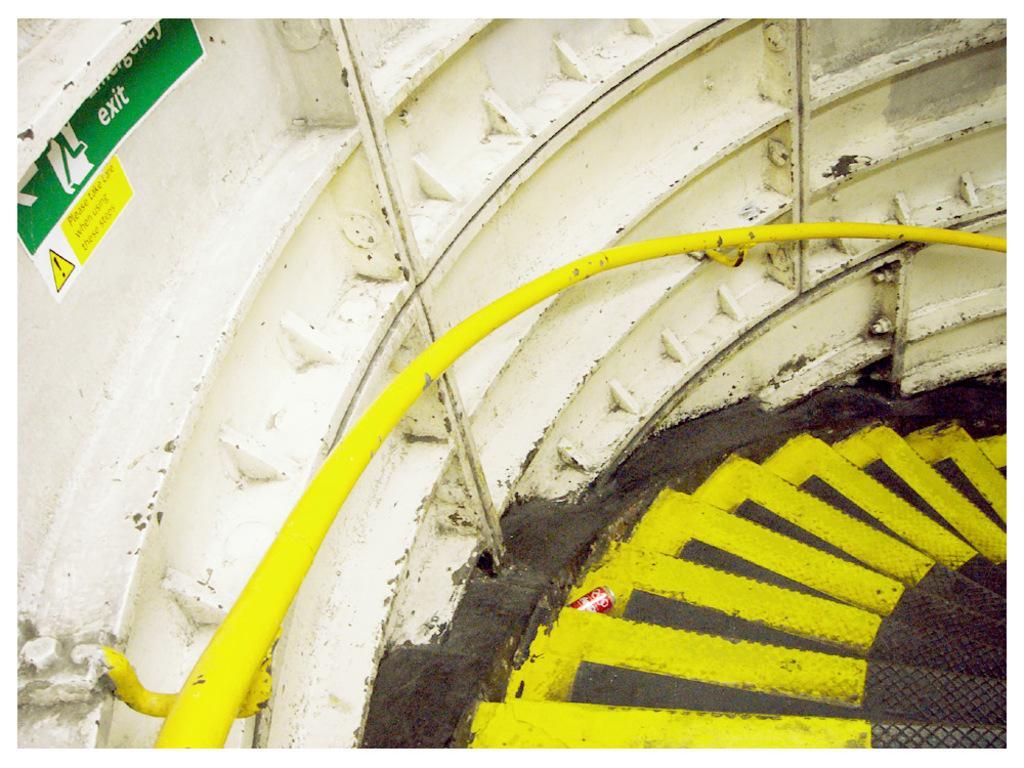Could you give a brief overview of what you see in this image? In this image we can see some stars which are in black and yellow color and in the background of the image we can see white color surface and there is some sign board. 